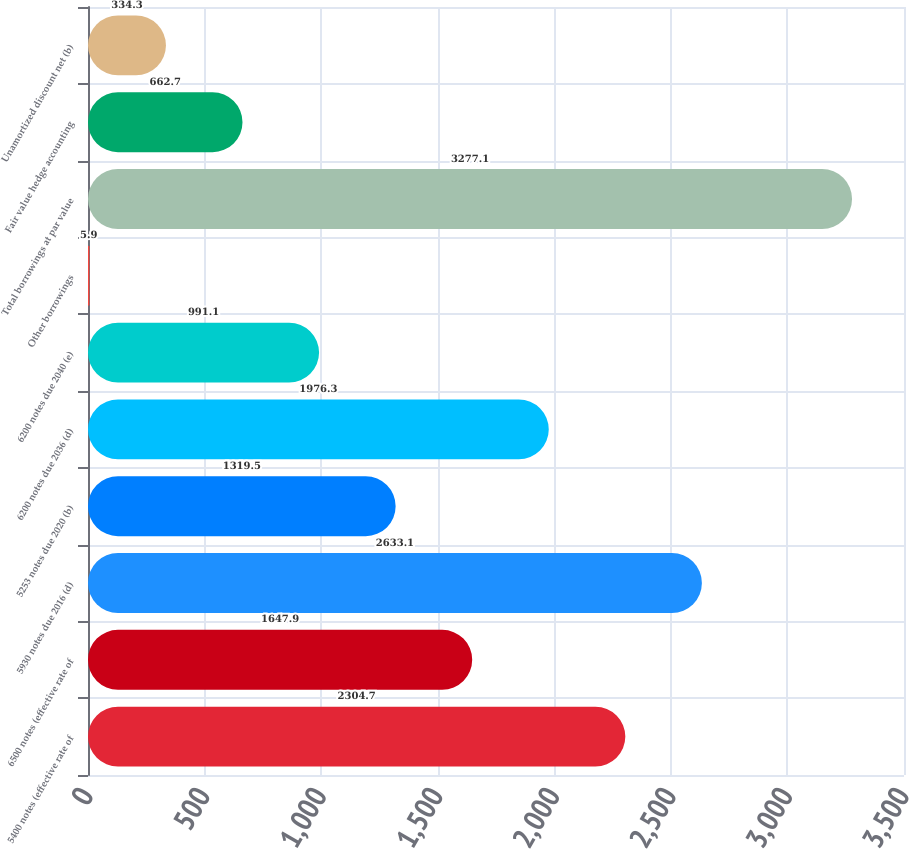Convert chart. <chart><loc_0><loc_0><loc_500><loc_500><bar_chart><fcel>5400 notes (effective rate of<fcel>6500 notes (effective rate of<fcel>5930 notes due 2016 (d)<fcel>5253 notes due 2020 (b)<fcel>6200 notes due 2036 (d)<fcel>6200 notes due 2040 (e)<fcel>Other borrowings<fcel>Total borrowings at par value<fcel>Fair value hedge accounting<fcel>Unamortized discount net (b)<nl><fcel>2304.7<fcel>1647.9<fcel>2633.1<fcel>1319.5<fcel>1976.3<fcel>991.1<fcel>5.9<fcel>3277.1<fcel>662.7<fcel>334.3<nl></chart> 